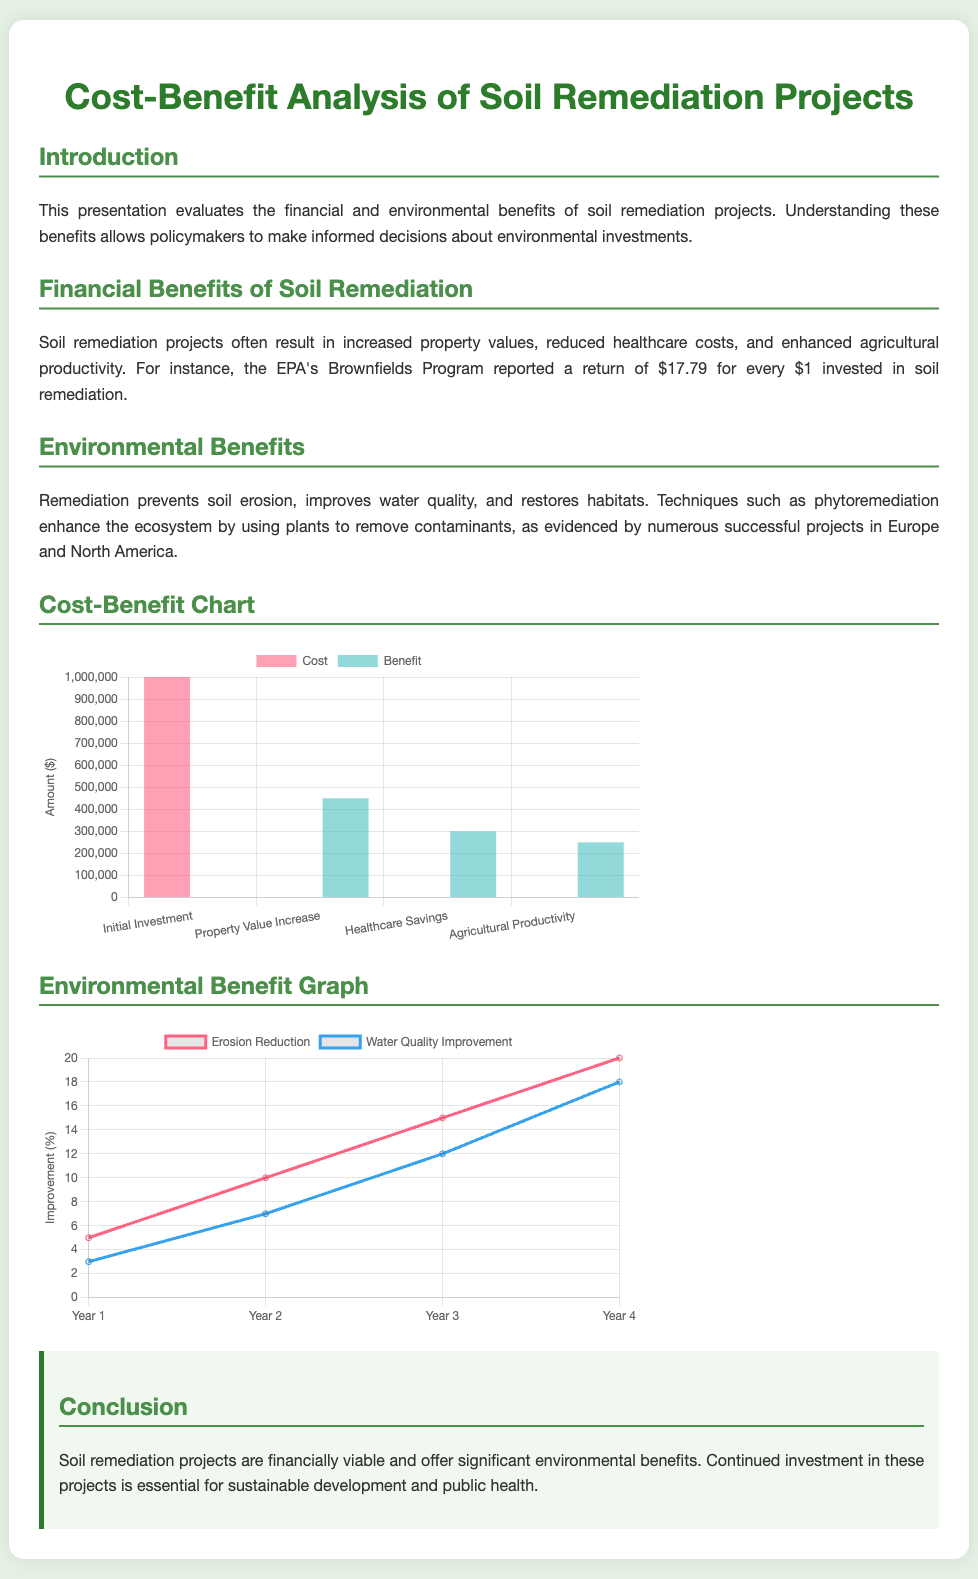What is the initial investment amount? The document states that the initial investment is $1,000,000.
Answer: $1,000,000 What is the return on investment reported by the EPA's Brownfields Program? The EPA's Brownfields Program reported a return of $17.79 for every $1 invested.
Answer: $17.79 What are the two categories of benefits highlighted in the presentation? The benefits are categorized as financial and environmental benefits.
Answer: Financial and environmental In which year does the water quality improvement reach 18%? According to the environmental benefit graph, water quality improvement reaches 18% in Year 4.
Answer: Year 4 What is the amount for property value increase? The document indicates that the increase in property value is $450,000.
Answer: $450,000 How many years are shown in the environmental benefit graph? The environmental benefit graph displays data for 4 years.
Answer: 4 years What type of chart is used for the cost-benefit analysis? The cost-benefit analysis is presented using a bar chart.
Answer: Bar chart What is the percentage of erosion reduction in Year 3? The erosion reduction reaches 15% in Year 3 according to the chart.
Answer: 15% What is the purpose of the presentation? The purpose is to evaluate the financial and environmental benefits of soil remediation projects.
Answer: Evaluate benefits 